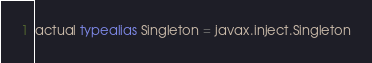Convert code to text. <code><loc_0><loc_0><loc_500><loc_500><_Kotlin_>actual typealias Singleton = javax.inject.Singleton
</code> 